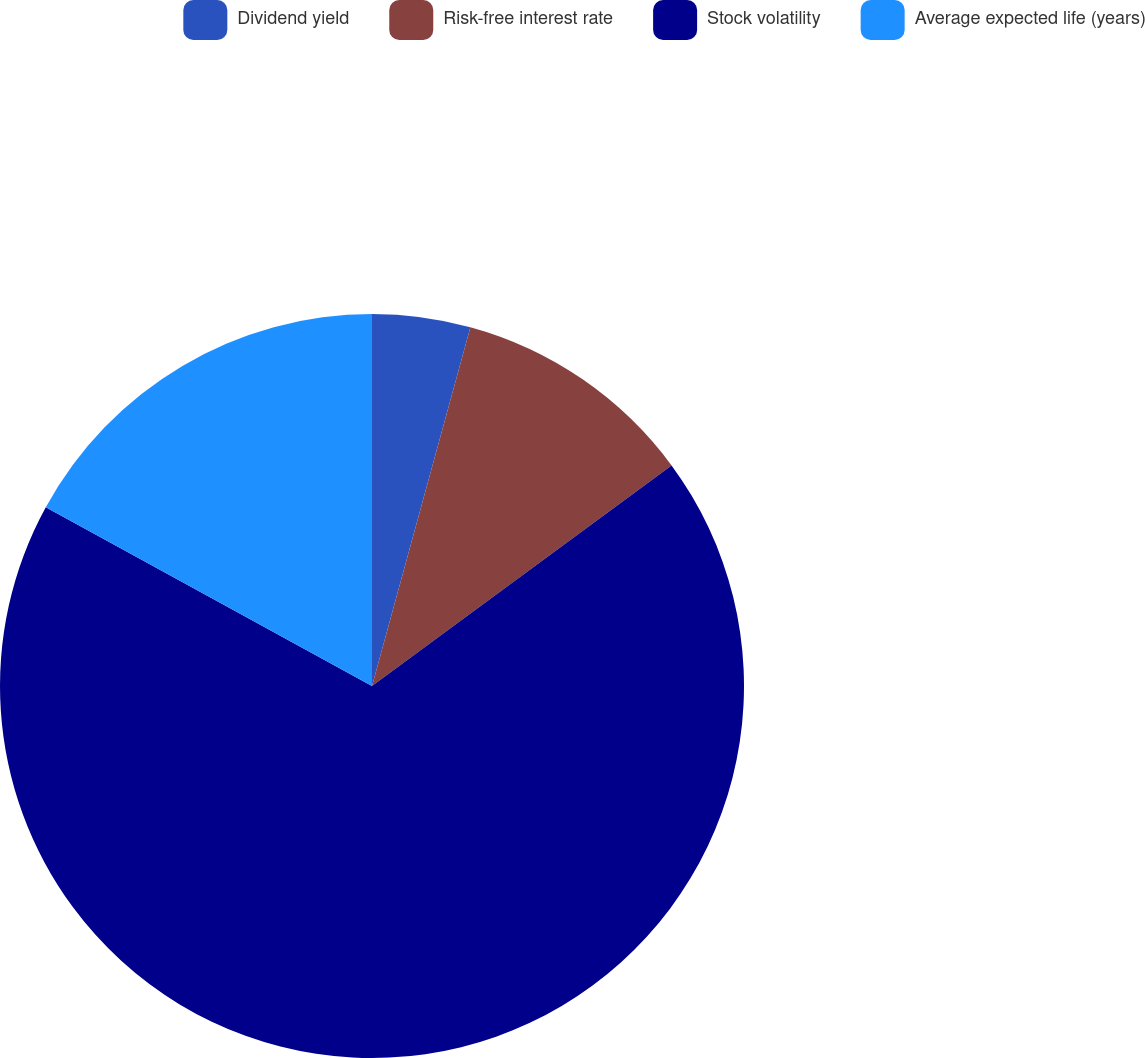<chart> <loc_0><loc_0><loc_500><loc_500><pie_chart><fcel>Dividend yield<fcel>Risk-free interest rate<fcel>Stock volatility<fcel>Average expected life (years)<nl><fcel>4.26%<fcel>10.64%<fcel>68.09%<fcel>17.02%<nl></chart> 